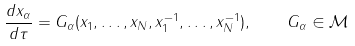<formula> <loc_0><loc_0><loc_500><loc_500>\frac { d x _ { \alpha } } { d \tau } = G _ { \alpha } ( x _ { 1 } , \dots , x _ { N } , x _ { 1 } ^ { - 1 } , \dots , x _ { N } ^ { - 1 } ) , \quad G _ { \alpha } \in { \mathcal { M } }</formula> 